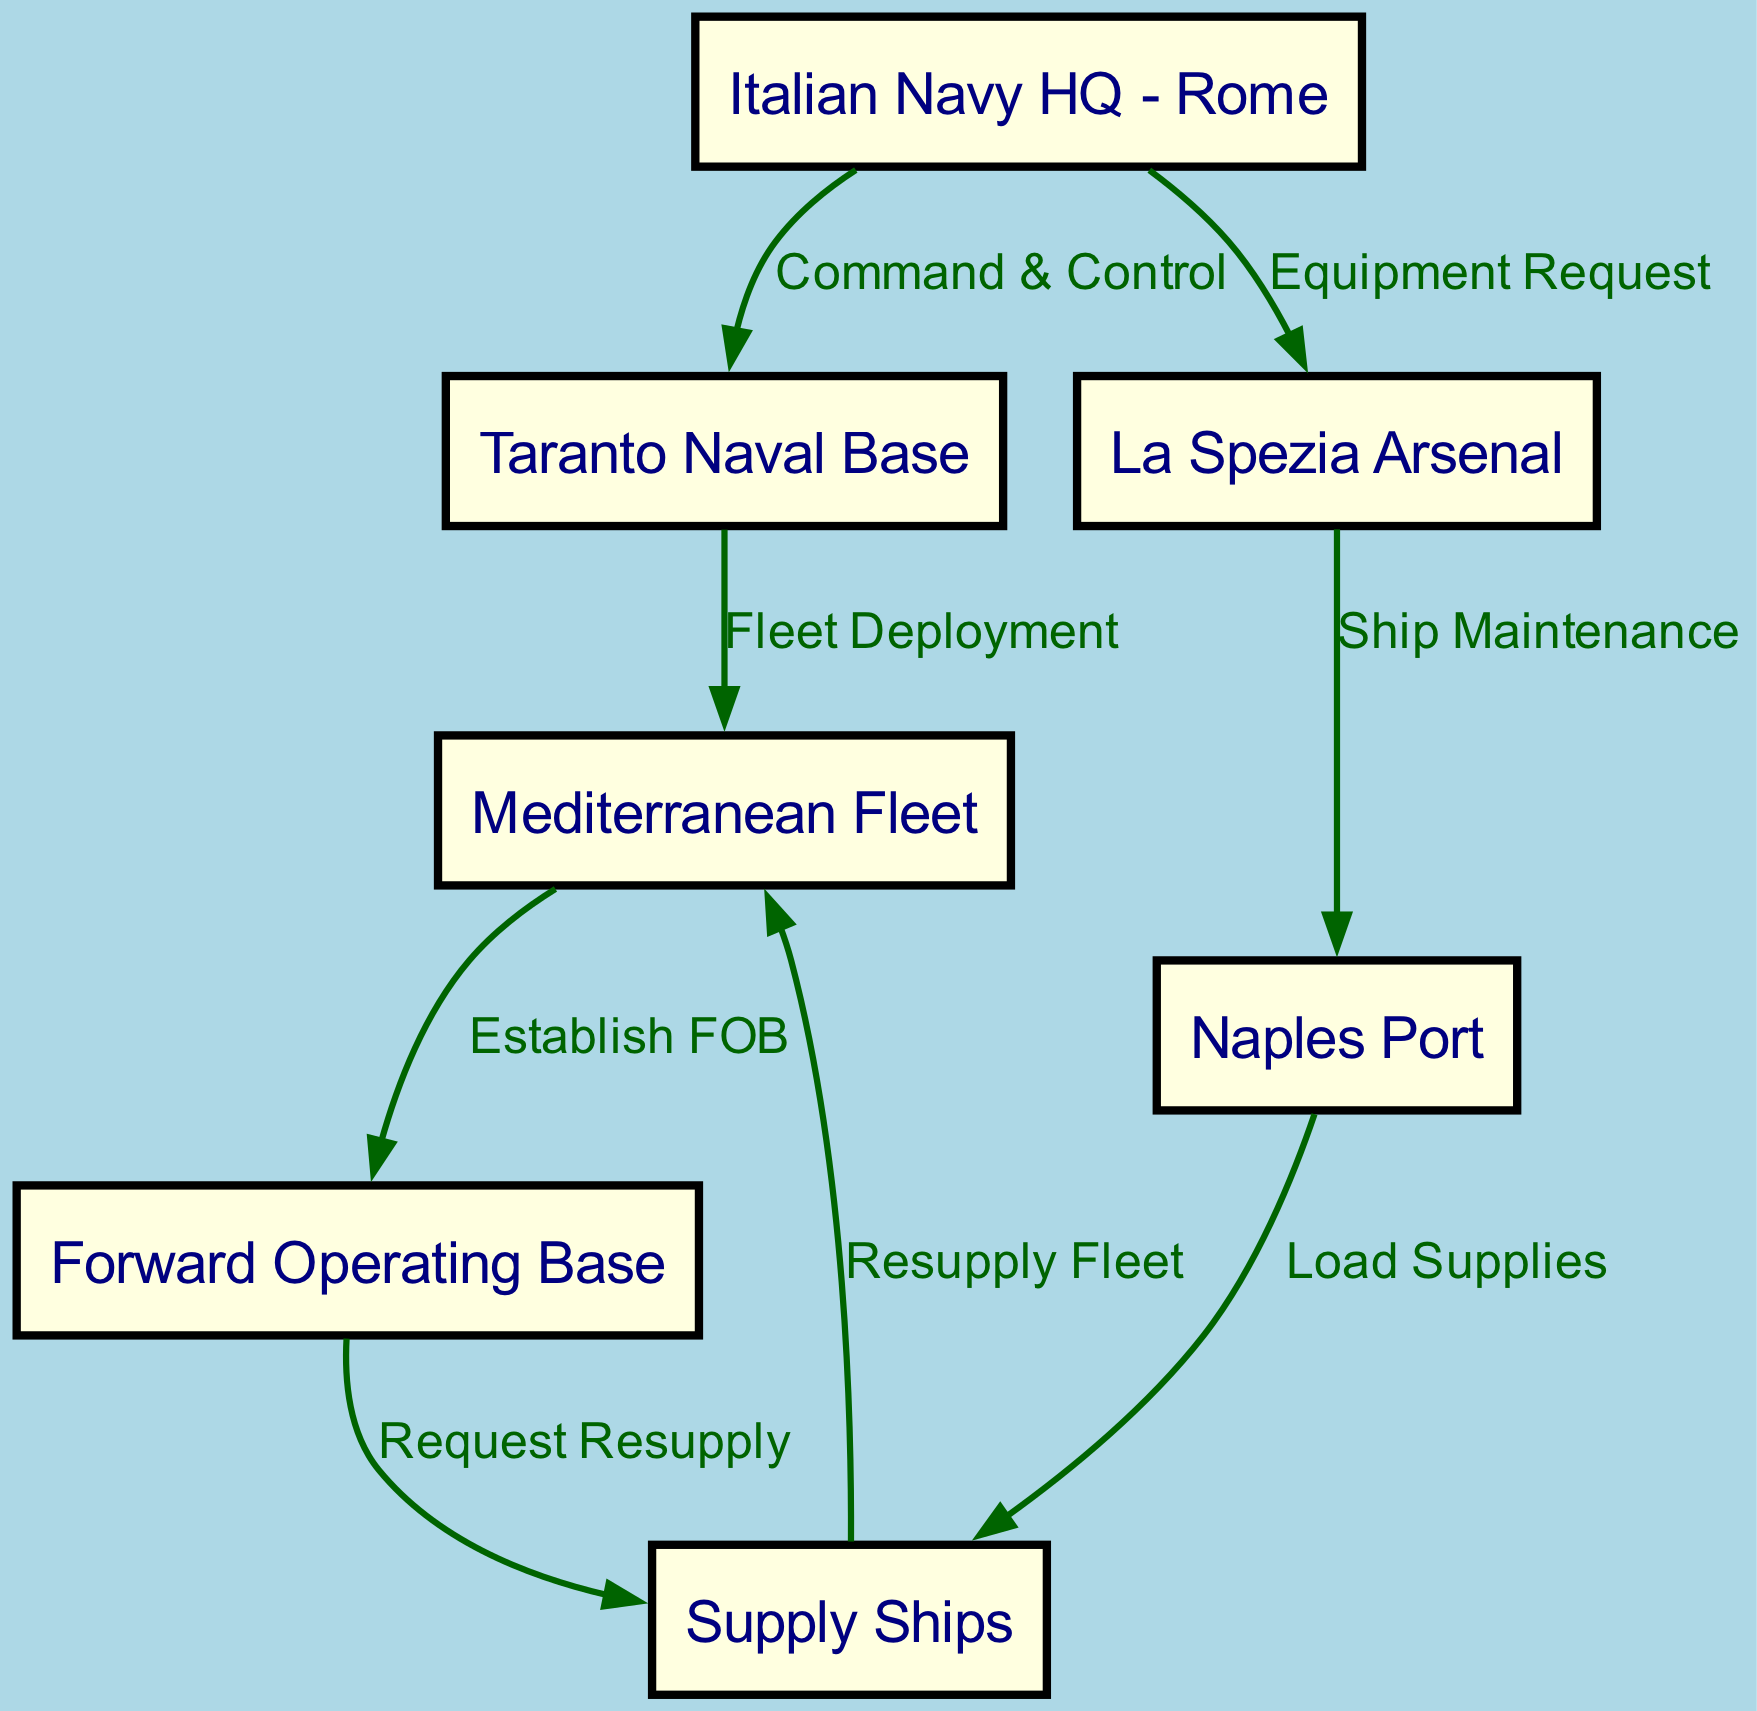What is the starting point of the logistics chain? The starting point is the Italian Navy HQ in Rome, which acts as the command and control center for the logistics operations.
Answer: Italian Navy HQ - Rome How many nodes are there in the diagram? The diagram consists of seven nodes representing different entities involved in the logistics and supply chain.
Answer: 7 What type of relationship exists between the Italian Navy HQ and Taranto Naval Base? The relationship is defined as "Command & Control," indicating that the HQ oversees the operations at the Taranto Naval Base.
Answer: Command & Control Which base is responsible for fleet deployment? The Taranto Naval Base is responsible for the deployment of the Mediterranean Fleet to carry out naval operations.
Answer: Taranto Naval Base What is the purpose of the edge between Naples Port and Supply Ships? The edge signifies the action of loading supplies onto the supply ships, which is essential for the fleet's operational readiness.
Answer: Load Supplies Which node establishes the Forward Operating Base? The Mediterranean Fleet is responsible for establishing the Forward Operating Base during the expedition, indicated by the flow directed towards the FOB.
Answer: Mediterranean Fleet How does the Forward Operating Base interact with the Supply Ships? The interaction involves a request for resupply, highlighting the need for additional resources to support operations at the FOB.
Answer: Request Resupply What is the relationship between the La Spezia Arsenal and Naples Port? The relationship is outlined as "Ship Maintenance," which indicates that maintenance activities are conducted for ships at the Naples Port originating from the Arsenal.
Answer: Ship Maintenance Which node provides a resupply to the Mediterranean Fleet? The Supply Ships provide resupply directly to the Mediterranean Fleet to ensure its continuous operation during the expedition.
Answer: Resupply Fleet 